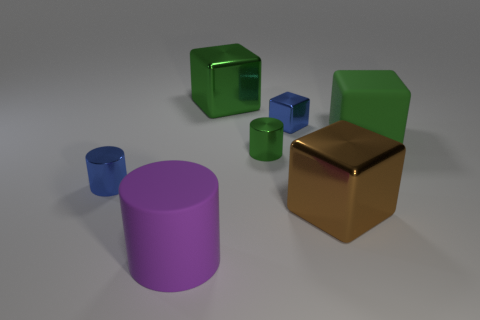Subtract all large rubber blocks. How many blocks are left? 3 Subtract 3 cylinders. How many cylinders are left? 0 Subtract all green cylinders. How many cylinders are left? 2 Add 2 tiny cylinders. How many objects exist? 9 Subtract all blocks. How many objects are left? 3 Subtract all cyan spheres. How many blue cylinders are left? 1 Add 6 small metal cubes. How many small metal cubes are left? 7 Add 4 brown metal objects. How many brown metal objects exist? 5 Subtract 2 green blocks. How many objects are left? 5 Subtract all cyan cylinders. Subtract all gray blocks. How many cylinders are left? 3 